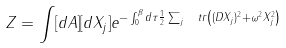<formula> <loc_0><loc_0><loc_500><loc_500>Z = \int [ d A ] [ d X _ { j } ] e ^ { - \int _ { 0 } ^ { \beta } d \tau \frac { 1 } { 2 } \sum _ { j } \ t r \left ( ( D X _ { j } ) ^ { 2 } + \omega ^ { 2 } X _ { j } ^ { 2 } \right ) }</formula> 